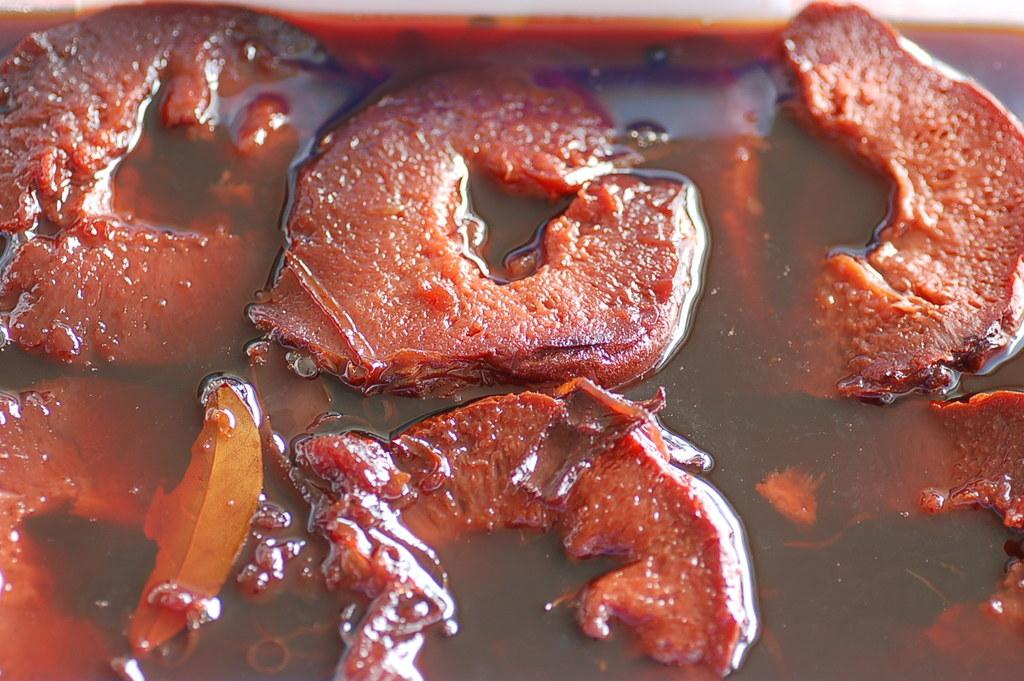What is the main subject of the image? There is a food item in the image. What type of slope can be seen in the image? There is no slope present in the image; it features a food item. Where might the person who prepared the food be vacationing? The image does not provide any information about the person who prepared the food or their vacation plans. 